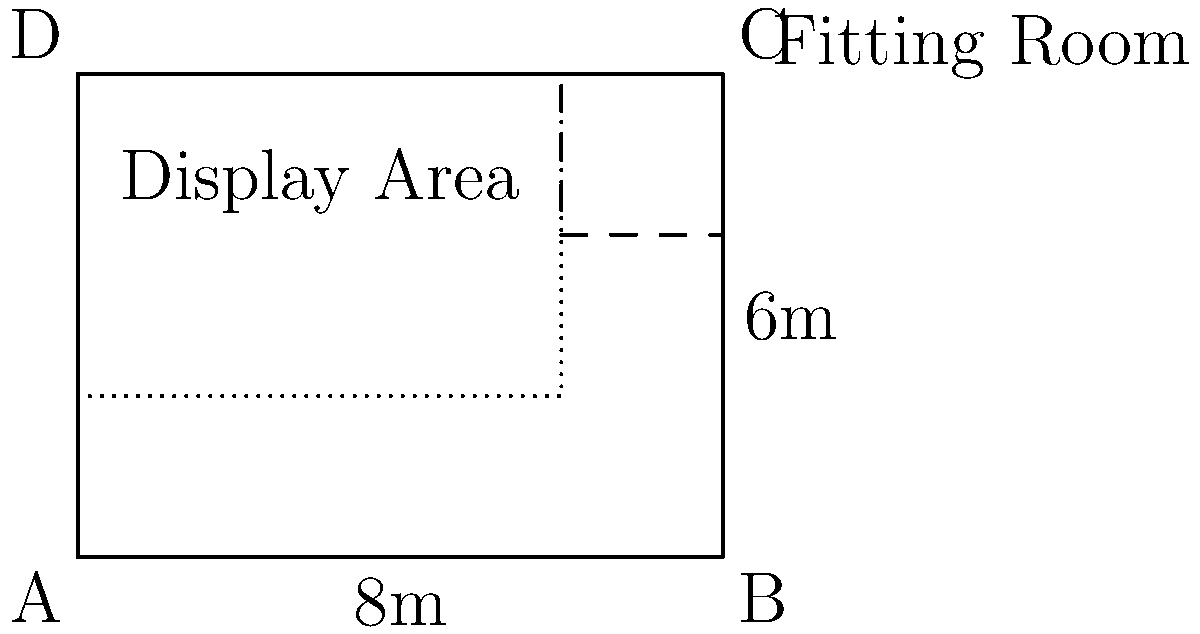You are designing the layout for your new boutique. The store has a rectangular shape with dimensions of 8m x 6m. You want to allocate 2m x 2m for a fitting room in the top right corner and use the remaining space for the display area. What is the area (in square meters) of the display area? To calculate the area of the display area, we need to follow these steps:

1. Calculate the total area of the boutique:
   Total Area = Length × Width
   Total Area = 8m × 6m = 48m²

2. Calculate the area of the fitting room:
   Fitting Room Area = Length × Width
   Fitting Room Area = 2m × 2m = 4m²

3. Calculate the display area by subtracting the fitting room area from the total area:
   Display Area = Total Area - Fitting Room Area
   Display Area = 48m² - 4m² = 44m²

Therefore, the area of the display area is 44 square meters.
Answer: 44m² 